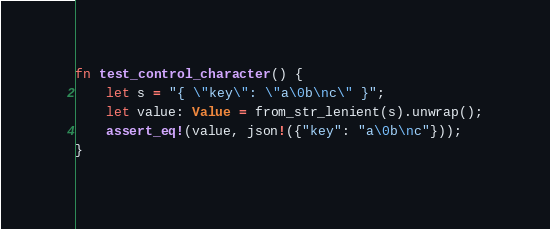Convert code to text. <code><loc_0><loc_0><loc_500><loc_500><_Rust_>fn test_control_character() {
    let s = "{ \"key\": \"a\0b\nc\" }";
    let value: Value = from_str_lenient(s).unwrap();
    assert_eq!(value, json!({"key": "a\0b\nc"}));
}
</code> 